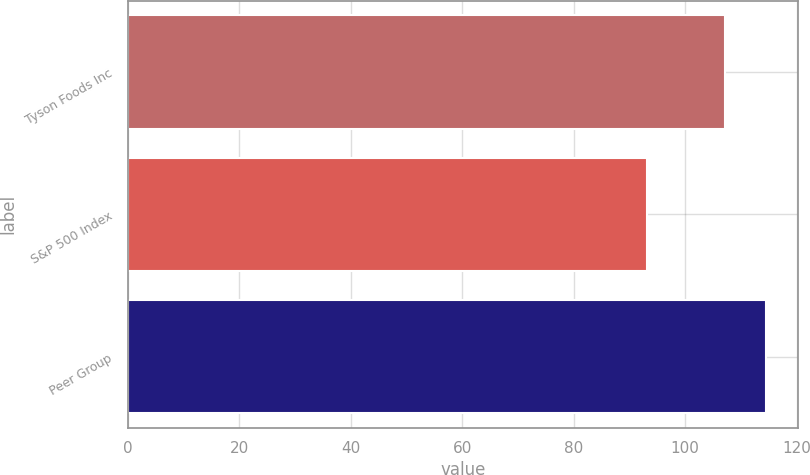Convert chart. <chart><loc_0><loc_0><loc_500><loc_500><bar_chart><fcel>Tyson Foods Inc<fcel>S&P 500 Index<fcel>Peer Group<nl><fcel>107.22<fcel>93.17<fcel>114.5<nl></chart> 